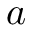<formula> <loc_0><loc_0><loc_500><loc_500>a</formula> 